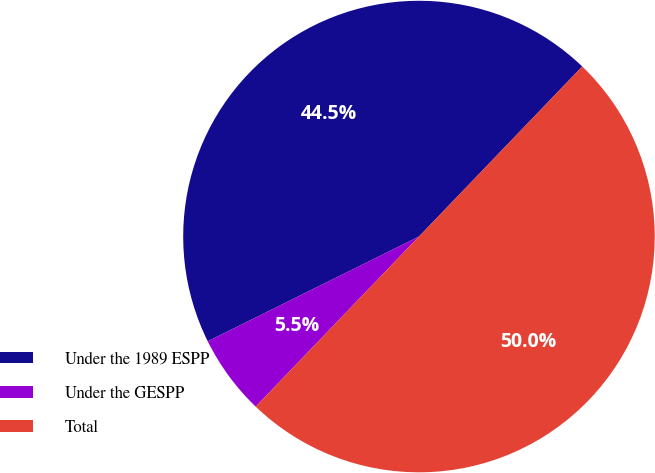Convert chart to OTSL. <chart><loc_0><loc_0><loc_500><loc_500><pie_chart><fcel>Under the 1989 ESPP<fcel>Under the GESPP<fcel>Total<nl><fcel>44.5%<fcel>5.5%<fcel>50.0%<nl></chart> 